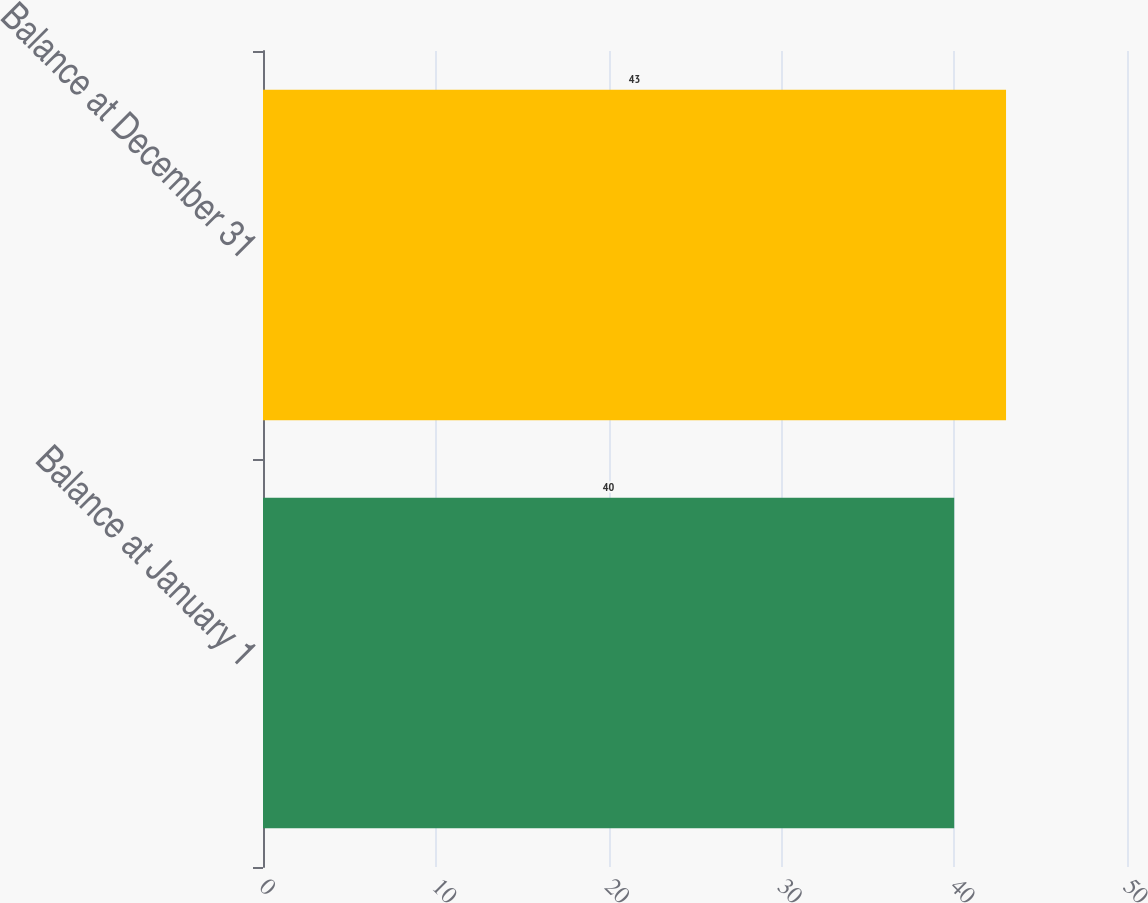<chart> <loc_0><loc_0><loc_500><loc_500><bar_chart><fcel>Balance at January 1<fcel>Balance at December 31<nl><fcel>40<fcel>43<nl></chart> 